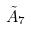<formula> <loc_0><loc_0><loc_500><loc_500>\tilde { A } _ { 7 }</formula> 